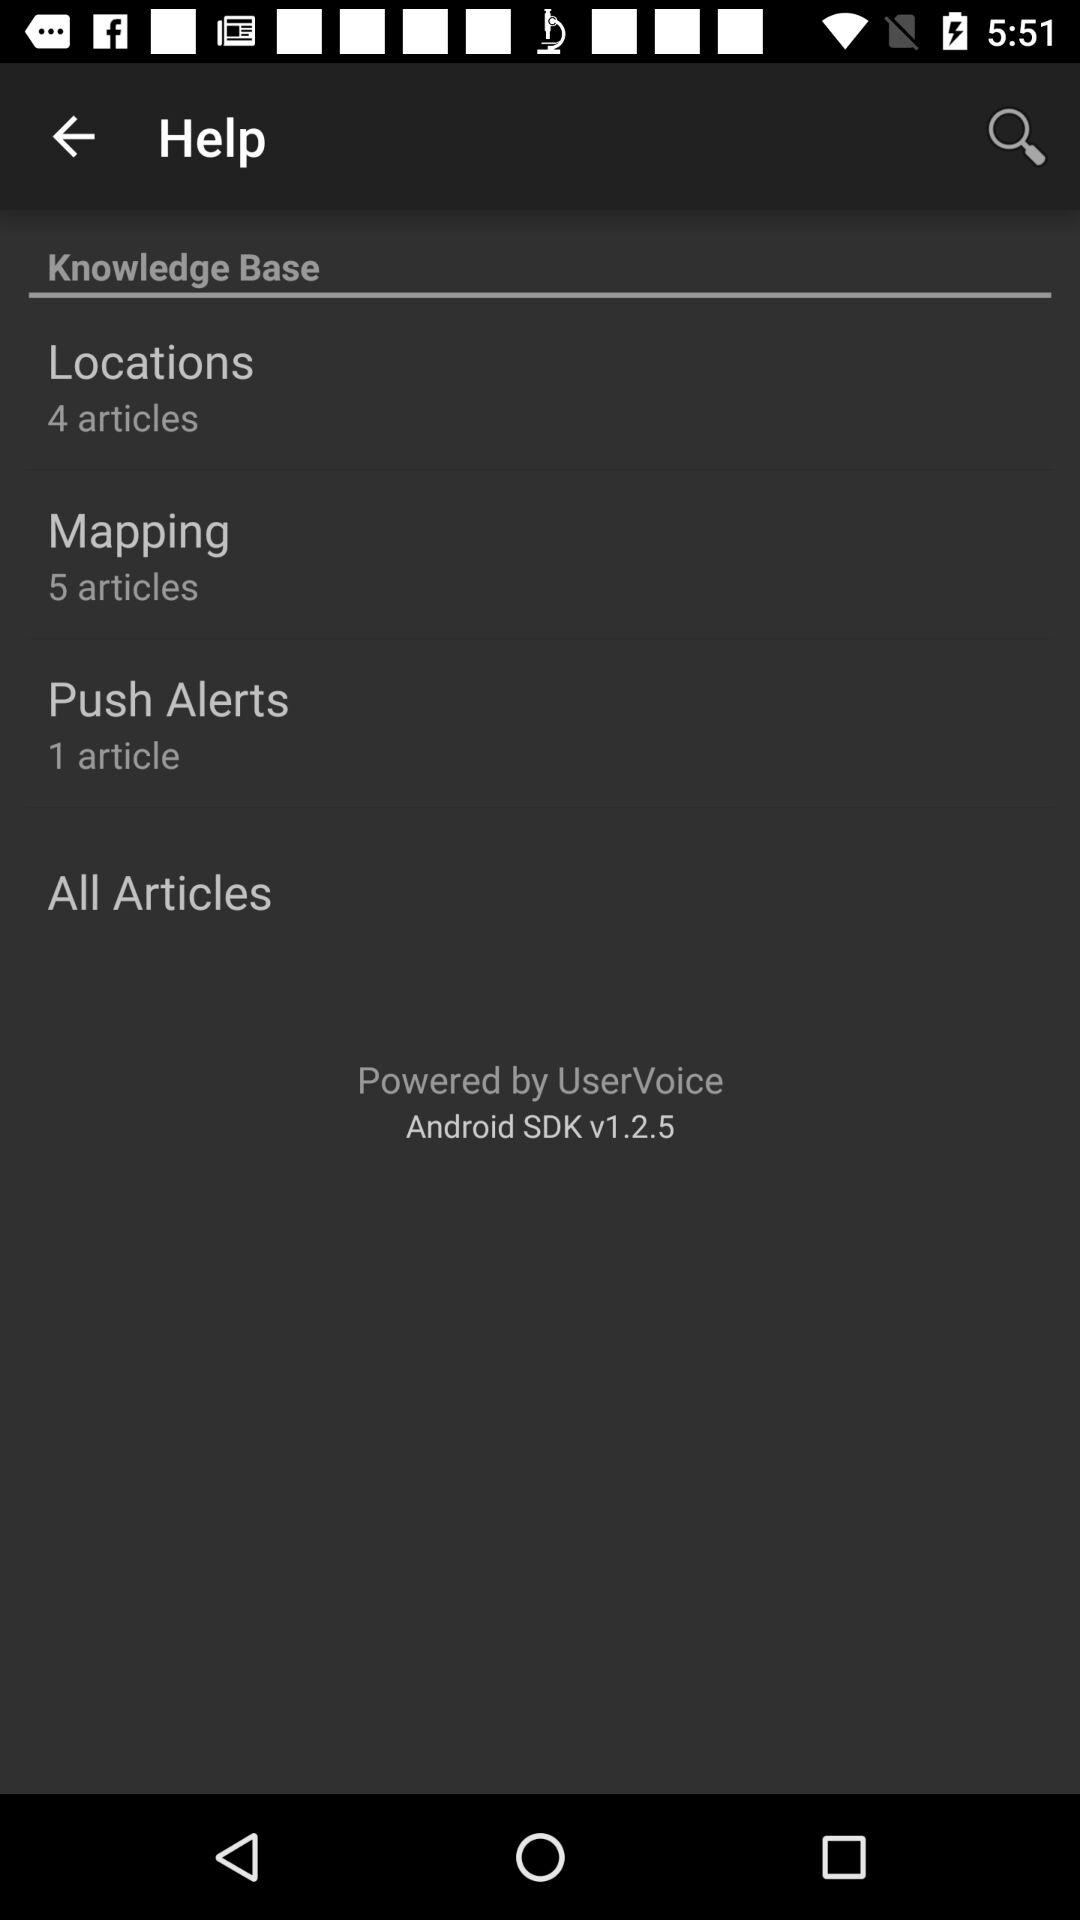How many articles are there in "Push Alerts"? There is 1 article in "Push Alerts". 